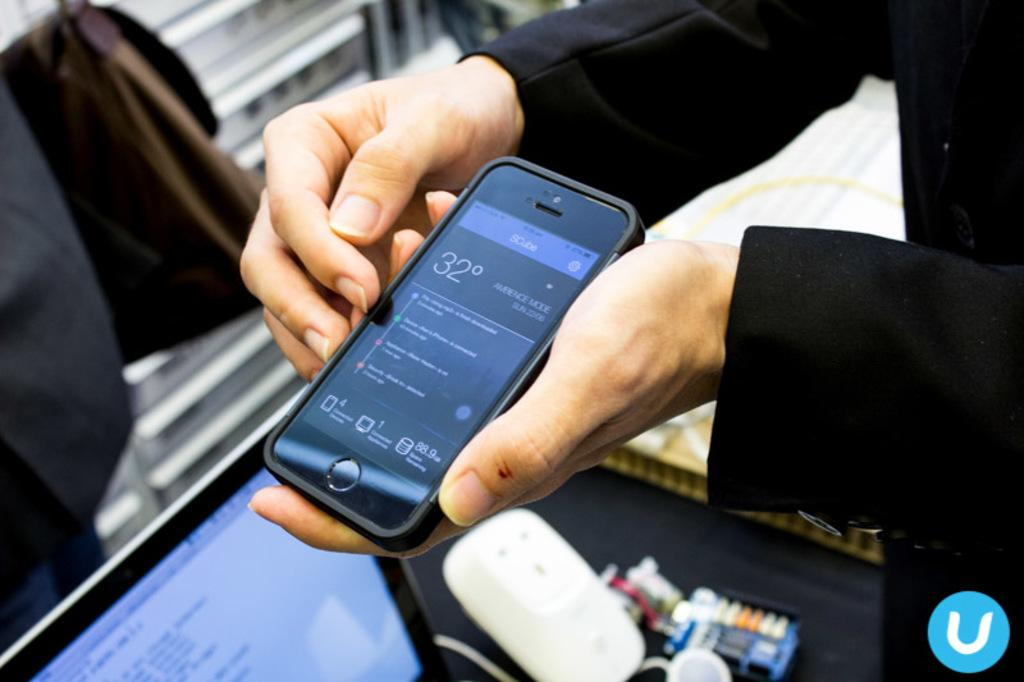<image>
Write a terse but informative summary of the picture. a man holding a SCube cell phone over the desk 